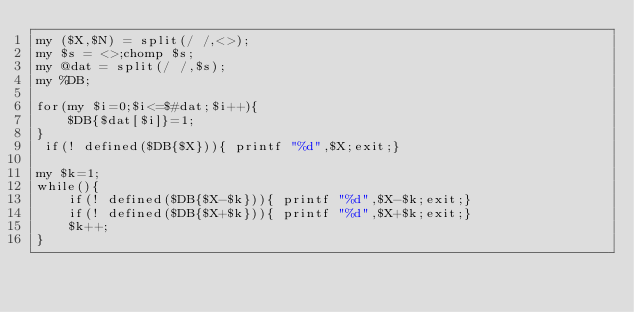<code> <loc_0><loc_0><loc_500><loc_500><_Perl_>my ($X,$N) = split(/ /,<>);
my $s = <>;chomp $s;
my @dat = split(/ /,$s);
my %DB;

for(my $i=0;$i<=$#dat;$i++){
    $DB{$dat[$i]}=1;
}
 if(! defined($DB{$X})){ printf "%d",$X;exit;}

my $k=1;
while(){
    if(! defined($DB{$X-$k})){ printf "%d",$X-$k;exit;}
    if(! defined($DB{$X+$k})){ printf "%d",$X+$k;exit;}
    $k++;
}</code> 